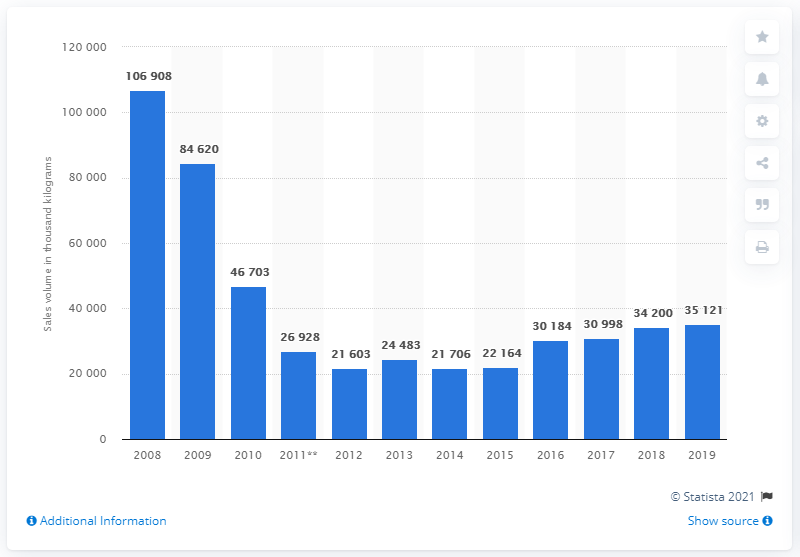Mention a couple of crucial points in this snapshot. In 2019, the sales volume of chocolate bars in the UK was approximately 35,121 units. The production volume of chocolate bars decreased significantly between 2008 and 2011, with a noticeable decline of 35,121 units. 